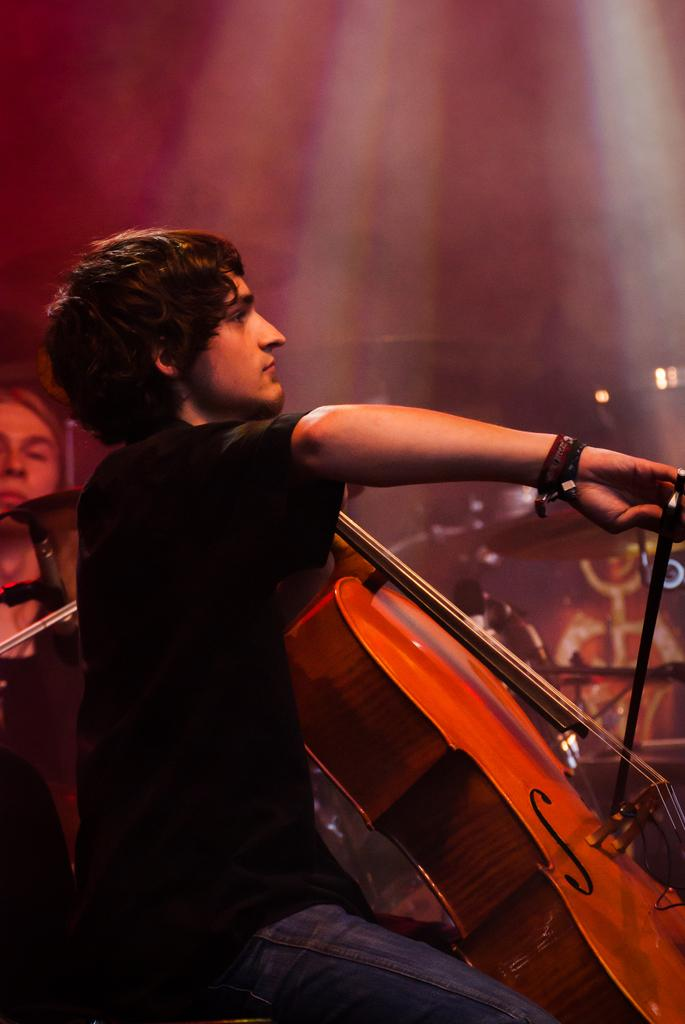Who is present in the image? There is a person in the image. What object can be seen with the person? There is a guitar in the image. Can you describe the other person in the image? A woman is visible in the image. What else is present in the image besides the people and guitar? Musical instruments are present in the image. What can be seen in the background of the image? There are lights and a wall in the background of the image. How would you describe the background of the image? The background is blurry. What type of weather can be seen through the window in the image? There is no window present in the image, so it is not possible to determine the weather. Can you describe the insect that is crawling on the guitar in the image? There is no insect present on the guitar in the image. 